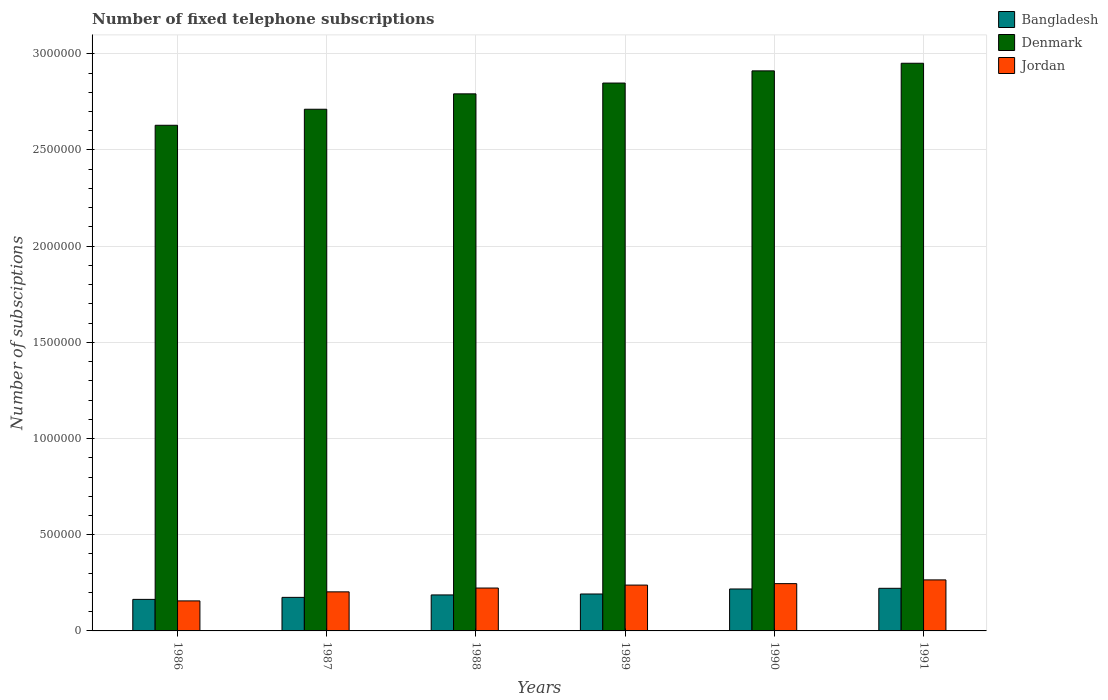How many different coloured bars are there?
Keep it short and to the point. 3. How many groups of bars are there?
Your response must be concise. 6. Are the number of bars per tick equal to the number of legend labels?
Provide a short and direct response. Yes. How many bars are there on the 4th tick from the right?
Offer a terse response. 3. In how many cases, is the number of bars for a given year not equal to the number of legend labels?
Provide a succinct answer. 0. What is the number of fixed telephone subscriptions in Bangladesh in 1987?
Give a very brief answer. 1.74e+05. Across all years, what is the maximum number of fixed telephone subscriptions in Jordan?
Provide a short and direct response. 2.65e+05. Across all years, what is the minimum number of fixed telephone subscriptions in Denmark?
Your response must be concise. 2.63e+06. In which year was the number of fixed telephone subscriptions in Jordan maximum?
Provide a succinct answer. 1991. In which year was the number of fixed telephone subscriptions in Denmark minimum?
Your answer should be compact. 1986. What is the total number of fixed telephone subscriptions in Bangladesh in the graph?
Offer a very short reply. 1.16e+06. What is the difference between the number of fixed telephone subscriptions in Bangladesh in 1987 and that in 1991?
Give a very brief answer. -4.71e+04. What is the difference between the number of fixed telephone subscriptions in Jordan in 1987 and the number of fixed telephone subscriptions in Bangladesh in 1991?
Your answer should be compact. -1.85e+04. What is the average number of fixed telephone subscriptions in Denmark per year?
Your answer should be very brief. 2.81e+06. In the year 1990, what is the difference between the number of fixed telephone subscriptions in Bangladesh and number of fixed telephone subscriptions in Denmark?
Ensure brevity in your answer.  -2.69e+06. What is the ratio of the number of fixed telephone subscriptions in Bangladesh in 1988 to that in 1991?
Keep it short and to the point. 0.84. Is the number of fixed telephone subscriptions in Bangladesh in 1987 less than that in 1988?
Your response must be concise. Yes. Is the difference between the number of fixed telephone subscriptions in Bangladesh in 1987 and 1990 greater than the difference between the number of fixed telephone subscriptions in Denmark in 1987 and 1990?
Your answer should be compact. Yes. What is the difference between the highest and the second highest number of fixed telephone subscriptions in Denmark?
Ensure brevity in your answer.  3.96e+04. What is the difference between the highest and the lowest number of fixed telephone subscriptions in Denmark?
Keep it short and to the point. 3.22e+05. Is the sum of the number of fixed telephone subscriptions in Denmark in 1987 and 1989 greater than the maximum number of fixed telephone subscriptions in Jordan across all years?
Your response must be concise. Yes. What does the 1st bar from the left in 1989 represents?
Offer a terse response. Bangladesh. Is it the case that in every year, the sum of the number of fixed telephone subscriptions in Denmark and number of fixed telephone subscriptions in Bangladesh is greater than the number of fixed telephone subscriptions in Jordan?
Make the answer very short. Yes. Are all the bars in the graph horizontal?
Offer a terse response. No. Are the values on the major ticks of Y-axis written in scientific E-notation?
Make the answer very short. No. Does the graph contain any zero values?
Provide a short and direct response. No. Does the graph contain grids?
Your answer should be very brief. Yes. What is the title of the graph?
Give a very brief answer. Number of fixed telephone subscriptions. Does "United States" appear as one of the legend labels in the graph?
Your response must be concise. No. What is the label or title of the X-axis?
Your answer should be very brief. Years. What is the label or title of the Y-axis?
Offer a very short reply. Number of subsciptions. What is the Number of subsciptions in Bangladesh in 1986?
Provide a succinct answer. 1.64e+05. What is the Number of subsciptions of Denmark in 1986?
Provide a short and direct response. 2.63e+06. What is the Number of subsciptions of Jordan in 1986?
Give a very brief answer. 1.56e+05. What is the Number of subsciptions in Bangladesh in 1987?
Keep it short and to the point. 1.74e+05. What is the Number of subsciptions of Denmark in 1987?
Provide a short and direct response. 2.71e+06. What is the Number of subsciptions of Jordan in 1987?
Your answer should be very brief. 2.03e+05. What is the Number of subsciptions of Bangladesh in 1988?
Keep it short and to the point. 1.87e+05. What is the Number of subsciptions of Denmark in 1988?
Your response must be concise. 2.79e+06. What is the Number of subsciptions in Jordan in 1988?
Keep it short and to the point. 2.23e+05. What is the Number of subsciptions of Bangladesh in 1989?
Offer a very short reply. 1.92e+05. What is the Number of subsciptions in Denmark in 1989?
Keep it short and to the point. 2.85e+06. What is the Number of subsciptions in Jordan in 1989?
Give a very brief answer. 2.38e+05. What is the Number of subsciptions in Bangladesh in 1990?
Give a very brief answer. 2.18e+05. What is the Number of subsciptions of Denmark in 1990?
Offer a terse response. 2.91e+06. What is the Number of subsciptions in Jordan in 1990?
Give a very brief answer. 2.46e+05. What is the Number of subsciptions of Bangladesh in 1991?
Provide a succinct answer. 2.22e+05. What is the Number of subsciptions of Denmark in 1991?
Offer a very short reply. 2.95e+06. What is the Number of subsciptions in Jordan in 1991?
Give a very brief answer. 2.65e+05. Across all years, what is the maximum Number of subsciptions in Bangladesh?
Your response must be concise. 2.22e+05. Across all years, what is the maximum Number of subsciptions of Denmark?
Provide a succinct answer. 2.95e+06. Across all years, what is the maximum Number of subsciptions in Jordan?
Your response must be concise. 2.65e+05. Across all years, what is the minimum Number of subsciptions in Bangladesh?
Ensure brevity in your answer.  1.64e+05. Across all years, what is the minimum Number of subsciptions in Denmark?
Your answer should be very brief. 2.63e+06. Across all years, what is the minimum Number of subsciptions of Jordan?
Offer a terse response. 1.56e+05. What is the total Number of subsciptions in Bangladesh in the graph?
Make the answer very short. 1.16e+06. What is the total Number of subsciptions in Denmark in the graph?
Provide a succinct answer. 1.68e+07. What is the total Number of subsciptions of Jordan in the graph?
Your answer should be very brief. 1.33e+06. What is the difference between the Number of subsciptions in Bangladesh in 1986 and that in 1987?
Your answer should be very brief. -1.05e+04. What is the difference between the Number of subsciptions of Denmark in 1986 and that in 1987?
Your response must be concise. -8.33e+04. What is the difference between the Number of subsciptions of Jordan in 1986 and that in 1987?
Provide a succinct answer. -4.70e+04. What is the difference between the Number of subsciptions of Bangladesh in 1986 and that in 1988?
Make the answer very short. -2.32e+04. What is the difference between the Number of subsciptions of Denmark in 1986 and that in 1988?
Your response must be concise. -1.63e+05. What is the difference between the Number of subsciptions in Jordan in 1986 and that in 1988?
Keep it short and to the point. -6.69e+04. What is the difference between the Number of subsciptions of Bangladesh in 1986 and that in 1989?
Your answer should be compact. -2.81e+04. What is the difference between the Number of subsciptions in Denmark in 1986 and that in 1989?
Your answer should be very brief. -2.20e+05. What is the difference between the Number of subsciptions in Jordan in 1986 and that in 1989?
Provide a succinct answer. -8.23e+04. What is the difference between the Number of subsciptions of Bangladesh in 1986 and that in 1990?
Give a very brief answer. -5.41e+04. What is the difference between the Number of subsciptions in Denmark in 1986 and that in 1990?
Offer a terse response. -2.83e+05. What is the difference between the Number of subsciptions of Jordan in 1986 and that in 1990?
Make the answer very short. -8.98e+04. What is the difference between the Number of subsciptions of Bangladesh in 1986 and that in 1991?
Your answer should be compact. -5.76e+04. What is the difference between the Number of subsciptions of Denmark in 1986 and that in 1991?
Make the answer very short. -3.22e+05. What is the difference between the Number of subsciptions of Jordan in 1986 and that in 1991?
Ensure brevity in your answer.  -1.09e+05. What is the difference between the Number of subsciptions of Bangladesh in 1987 and that in 1988?
Ensure brevity in your answer.  -1.27e+04. What is the difference between the Number of subsciptions in Denmark in 1987 and that in 1988?
Provide a succinct answer. -8.00e+04. What is the difference between the Number of subsciptions of Jordan in 1987 and that in 1988?
Keep it short and to the point. -1.98e+04. What is the difference between the Number of subsciptions in Bangladesh in 1987 and that in 1989?
Make the answer very short. -1.76e+04. What is the difference between the Number of subsciptions in Denmark in 1987 and that in 1989?
Your response must be concise. -1.36e+05. What is the difference between the Number of subsciptions in Jordan in 1987 and that in 1989?
Offer a terse response. -3.52e+04. What is the difference between the Number of subsciptions in Bangladesh in 1987 and that in 1990?
Your response must be concise. -4.36e+04. What is the difference between the Number of subsciptions in Denmark in 1987 and that in 1990?
Your response must be concise. -2.00e+05. What is the difference between the Number of subsciptions of Jordan in 1987 and that in 1990?
Provide a short and direct response. -4.27e+04. What is the difference between the Number of subsciptions of Bangladesh in 1987 and that in 1991?
Offer a very short reply. -4.71e+04. What is the difference between the Number of subsciptions in Denmark in 1987 and that in 1991?
Make the answer very short. -2.39e+05. What is the difference between the Number of subsciptions in Jordan in 1987 and that in 1991?
Your answer should be very brief. -6.22e+04. What is the difference between the Number of subsciptions of Bangladesh in 1988 and that in 1989?
Provide a short and direct response. -4900. What is the difference between the Number of subsciptions in Denmark in 1988 and that in 1989?
Your answer should be very brief. -5.61e+04. What is the difference between the Number of subsciptions of Jordan in 1988 and that in 1989?
Give a very brief answer. -1.54e+04. What is the difference between the Number of subsciptions in Bangladesh in 1988 and that in 1990?
Your answer should be compact. -3.09e+04. What is the difference between the Number of subsciptions of Denmark in 1988 and that in 1990?
Give a very brief answer. -1.19e+05. What is the difference between the Number of subsciptions of Jordan in 1988 and that in 1990?
Make the answer very short. -2.29e+04. What is the difference between the Number of subsciptions of Bangladesh in 1988 and that in 1991?
Provide a short and direct response. -3.44e+04. What is the difference between the Number of subsciptions in Denmark in 1988 and that in 1991?
Your answer should be compact. -1.59e+05. What is the difference between the Number of subsciptions of Jordan in 1988 and that in 1991?
Offer a very short reply. -4.23e+04. What is the difference between the Number of subsciptions in Bangladesh in 1989 and that in 1990?
Provide a short and direct response. -2.60e+04. What is the difference between the Number of subsciptions of Denmark in 1989 and that in 1990?
Provide a succinct answer. -6.33e+04. What is the difference between the Number of subsciptions of Jordan in 1989 and that in 1990?
Your response must be concise. -7490. What is the difference between the Number of subsciptions in Bangladesh in 1989 and that in 1991?
Keep it short and to the point. -2.95e+04. What is the difference between the Number of subsciptions in Denmark in 1989 and that in 1991?
Give a very brief answer. -1.03e+05. What is the difference between the Number of subsciptions of Jordan in 1989 and that in 1991?
Provide a short and direct response. -2.69e+04. What is the difference between the Number of subsciptions in Bangladesh in 1990 and that in 1991?
Your answer should be very brief. -3513. What is the difference between the Number of subsciptions in Denmark in 1990 and that in 1991?
Ensure brevity in your answer.  -3.96e+04. What is the difference between the Number of subsciptions of Jordan in 1990 and that in 1991?
Give a very brief answer. -1.94e+04. What is the difference between the Number of subsciptions of Bangladesh in 1986 and the Number of subsciptions of Denmark in 1987?
Offer a terse response. -2.55e+06. What is the difference between the Number of subsciptions of Bangladesh in 1986 and the Number of subsciptions of Jordan in 1987?
Provide a short and direct response. -3.92e+04. What is the difference between the Number of subsciptions in Denmark in 1986 and the Number of subsciptions in Jordan in 1987?
Keep it short and to the point. 2.43e+06. What is the difference between the Number of subsciptions in Bangladesh in 1986 and the Number of subsciptions in Denmark in 1988?
Offer a terse response. -2.63e+06. What is the difference between the Number of subsciptions of Bangladesh in 1986 and the Number of subsciptions of Jordan in 1988?
Your answer should be very brief. -5.90e+04. What is the difference between the Number of subsciptions of Denmark in 1986 and the Number of subsciptions of Jordan in 1988?
Provide a succinct answer. 2.41e+06. What is the difference between the Number of subsciptions in Bangladesh in 1986 and the Number of subsciptions in Denmark in 1989?
Give a very brief answer. -2.68e+06. What is the difference between the Number of subsciptions of Bangladesh in 1986 and the Number of subsciptions of Jordan in 1989?
Your response must be concise. -7.44e+04. What is the difference between the Number of subsciptions of Denmark in 1986 and the Number of subsciptions of Jordan in 1989?
Offer a very short reply. 2.39e+06. What is the difference between the Number of subsciptions in Bangladesh in 1986 and the Number of subsciptions in Denmark in 1990?
Offer a very short reply. -2.75e+06. What is the difference between the Number of subsciptions in Bangladesh in 1986 and the Number of subsciptions in Jordan in 1990?
Offer a terse response. -8.19e+04. What is the difference between the Number of subsciptions in Denmark in 1986 and the Number of subsciptions in Jordan in 1990?
Your answer should be compact. 2.38e+06. What is the difference between the Number of subsciptions of Bangladesh in 1986 and the Number of subsciptions of Denmark in 1991?
Provide a short and direct response. -2.79e+06. What is the difference between the Number of subsciptions in Bangladesh in 1986 and the Number of subsciptions in Jordan in 1991?
Provide a short and direct response. -1.01e+05. What is the difference between the Number of subsciptions of Denmark in 1986 and the Number of subsciptions of Jordan in 1991?
Your answer should be compact. 2.36e+06. What is the difference between the Number of subsciptions in Bangladesh in 1987 and the Number of subsciptions in Denmark in 1988?
Provide a succinct answer. -2.62e+06. What is the difference between the Number of subsciptions of Bangladesh in 1987 and the Number of subsciptions of Jordan in 1988?
Provide a succinct answer. -4.85e+04. What is the difference between the Number of subsciptions of Denmark in 1987 and the Number of subsciptions of Jordan in 1988?
Your answer should be very brief. 2.49e+06. What is the difference between the Number of subsciptions in Bangladesh in 1987 and the Number of subsciptions in Denmark in 1989?
Offer a very short reply. -2.67e+06. What is the difference between the Number of subsciptions in Bangladesh in 1987 and the Number of subsciptions in Jordan in 1989?
Give a very brief answer. -6.39e+04. What is the difference between the Number of subsciptions in Denmark in 1987 and the Number of subsciptions in Jordan in 1989?
Ensure brevity in your answer.  2.47e+06. What is the difference between the Number of subsciptions of Bangladesh in 1987 and the Number of subsciptions of Denmark in 1990?
Your response must be concise. -2.74e+06. What is the difference between the Number of subsciptions in Bangladesh in 1987 and the Number of subsciptions in Jordan in 1990?
Make the answer very short. -7.14e+04. What is the difference between the Number of subsciptions in Denmark in 1987 and the Number of subsciptions in Jordan in 1990?
Provide a succinct answer. 2.47e+06. What is the difference between the Number of subsciptions in Bangladesh in 1987 and the Number of subsciptions in Denmark in 1991?
Your response must be concise. -2.78e+06. What is the difference between the Number of subsciptions of Bangladesh in 1987 and the Number of subsciptions of Jordan in 1991?
Provide a succinct answer. -9.08e+04. What is the difference between the Number of subsciptions in Denmark in 1987 and the Number of subsciptions in Jordan in 1991?
Ensure brevity in your answer.  2.45e+06. What is the difference between the Number of subsciptions in Bangladesh in 1988 and the Number of subsciptions in Denmark in 1989?
Keep it short and to the point. -2.66e+06. What is the difference between the Number of subsciptions in Bangladesh in 1988 and the Number of subsciptions in Jordan in 1989?
Provide a short and direct response. -5.12e+04. What is the difference between the Number of subsciptions of Denmark in 1988 and the Number of subsciptions of Jordan in 1989?
Your response must be concise. 2.55e+06. What is the difference between the Number of subsciptions of Bangladesh in 1988 and the Number of subsciptions of Denmark in 1990?
Make the answer very short. -2.72e+06. What is the difference between the Number of subsciptions in Bangladesh in 1988 and the Number of subsciptions in Jordan in 1990?
Offer a terse response. -5.87e+04. What is the difference between the Number of subsciptions in Denmark in 1988 and the Number of subsciptions in Jordan in 1990?
Your answer should be very brief. 2.55e+06. What is the difference between the Number of subsciptions of Bangladesh in 1988 and the Number of subsciptions of Denmark in 1991?
Keep it short and to the point. -2.76e+06. What is the difference between the Number of subsciptions in Bangladesh in 1988 and the Number of subsciptions in Jordan in 1991?
Keep it short and to the point. -7.81e+04. What is the difference between the Number of subsciptions in Denmark in 1988 and the Number of subsciptions in Jordan in 1991?
Your answer should be compact. 2.53e+06. What is the difference between the Number of subsciptions of Bangladesh in 1989 and the Number of subsciptions of Denmark in 1990?
Provide a succinct answer. -2.72e+06. What is the difference between the Number of subsciptions of Bangladesh in 1989 and the Number of subsciptions of Jordan in 1990?
Ensure brevity in your answer.  -5.38e+04. What is the difference between the Number of subsciptions in Denmark in 1989 and the Number of subsciptions in Jordan in 1990?
Offer a very short reply. 2.60e+06. What is the difference between the Number of subsciptions of Bangladesh in 1989 and the Number of subsciptions of Denmark in 1991?
Your answer should be compact. -2.76e+06. What is the difference between the Number of subsciptions of Bangladesh in 1989 and the Number of subsciptions of Jordan in 1991?
Offer a very short reply. -7.32e+04. What is the difference between the Number of subsciptions in Denmark in 1989 and the Number of subsciptions in Jordan in 1991?
Give a very brief answer. 2.58e+06. What is the difference between the Number of subsciptions in Bangladesh in 1990 and the Number of subsciptions in Denmark in 1991?
Your answer should be compact. -2.73e+06. What is the difference between the Number of subsciptions in Bangladesh in 1990 and the Number of subsciptions in Jordan in 1991?
Your answer should be compact. -4.72e+04. What is the difference between the Number of subsciptions of Denmark in 1990 and the Number of subsciptions of Jordan in 1991?
Ensure brevity in your answer.  2.65e+06. What is the average Number of subsciptions of Bangladesh per year?
Your response must be concise. 1.93e+05. What is the average Number of subsciptions of Denmark per year?
Give a very brief answer. 2.81e+06. What is the average Number of subsciptions in Jordan per year?
Give a very brief answer. 2.22e+05. In the year 1986, what is the difference between the Number of subsciptions in Bangladesh and Number of subsciptions in Denmark?
Your answer should be compact. -2.46e+06. In the year 1986, what is the difference between the Number of subsciptions in Bangladesh and Number of subsciptions in Jordan?
Ensure brevity in your answer.  7876. In the year 1986, what is the difference between the Number of subsciptions in Denmark and Number of subsciptions in Jordan?
Your response must be concise. 2.47e+06. In the year 1987, what is the difference between the Number of subsciptions of Bangladesh and Number of subsciptions of Denmark?
Keep it short and to the point. -2.54e+06. In the year 1987, what is the difference between the Number of subsciptions of Bangladesh and Number of subsciptions of Jordan?
Ensure brevity in your answer.  -2.87e+04. In the year 1987, what is the difference between the Number of subsciptions of Denmark and Number of subsciptions of Jordan?
Keep it short and to the point. 2.51e+06. In the year 1988, what is the difference between the Number of subsciptions in Bangladesh and Number of subsciptions in Denmark?
Provide a short and direct response. -2.60e+06. In the year 1988, what is the difference between the Number of subsciptions in Bangladesh and Number of subsciptions in Jordan?
Keep it short and to the point. -3.58e+04. In the year 1988, what is the difference between the Number of subsciptions in Denmark and Number of subsciptions in Jordan?
Your response must be concise. 2.57e+06. In the year 1989, what is the difference between the Number of subsciptions of Bangladesh and Number of subsciptions of Denmark?
Your response must be concise. -2.66e+06. In the year 1989, what is the difference between the Number of subsciptions of Bangladesh and Number of subsciptions of Jordan?
Keep it short and to the point. -4.63e+04. In the year 1989, what is the difference between the Number of subsciptions in Denmark and Number of subsciptions in Jordan?
Offer a terse response. 2.61e+06. In the year 1990, what is the difference between the Number of subsciptions in Bangladesh and Number of subsciptions in Denmark?
Ensure brevity in your answer.  -2.69e+06. In the year 1990, what is the difference between the Number of subsciptions in Bangladesh and Number of subsciptions in Jordan?
Keep it short and to the point. -2.78e+04. In the year 1990, what is the difference between the Number of subsciptions of Denmark and Number of subsciptions of Jordan?
Your answer should be compact. 2.67e+06. In the year 1991, what is the difference between the Number of subsciptions of Bangladesh and Number of subsciptions of Denmark?
Your answer should be very brief. -2.73e+06. In the year 1991, what is the difference between the Number of subsciptions of Bangladesh and Number of subsciptions of Jordan?
Provide a short and direct response. -4.37e+04. In the year 1991, what is the difference between the Number of subsciptions in Denmark and Number of subsciptions in Jordan?
Make the answer very short. 2.69e+06. What is the ratio of the Number of subsciptions in Bangladesh in 1986 to that in 1987?
Offer a terse response. 0.94. What is the ratio of the Number of subsciptions of Denmark in 1986 to that in 1987?
Provide a short and direct response. 0.97. What is the ratio of the Number of subsciptions of Jordan in 1986 to that in 1987?
Offer a terse response. 0.77. What is the ratio of the Number of subsciptions of Bangladesh in 1986 to that in 1988?
Your answer should be very brief. 0.88. What is the ratio of the Number of subsciptions of Denmark in 1986 to that in 1988?
Keep it short and to the point. 0.94. What is the ratio of the Number of subsciptions of Jordan in 1986 to that in 1988?
Make the answer very short. 0.7. What is the ratio of the Number of subsciptions of Bangladesh in 1986 to that in 1989?
Make the answer very short. 0.85. What is the ratio of the Number of subsciptions in Denmark in 1986 to that in 1989?
Give a very brief answer. 0.92. What is the ratio of the Number of subsciptions in Jordan in 1986 to that in 1989?
Your response must be concise. 0.65. What is the ratio of the Number of subsciptions of Bangladesh in 1986 to that in 1990?
Give a very brief answer. 0.75. What is the ratio of the Number of subsciptions in Denmark in 1986 to that in 1990?
Offer a terse response. 0.9. What is the ratio of the Number of subsciptions of Jordan in 1986 to that in 1990?
Offer a very short reply. 0.63. What is the ratio of the Number of subsciptions in Bangladesh in 1986 to that in 1991?
Make the answer very short. 0.74. What is the ratio of the Number of subsciptions in Denmark in 1986 to that in 1991?
Offer a very short reply. 0.89. What is the ratio of the Number of subsciptions in Jordan in 1986 to that in 1991?
Offer a very short reply. 0.59. What is the ratio of the Number of subsciptions of Bangladesh in 1987 to that in 1988?
Provide a short and direct response. 0.93. What is the ratio of the Number of subsciptions of Denmark in 1987 to that in 1988?
Provide a succinct answer. 0.97. What is the ratio of the Number of subsciptions of Jordan in 1987 to that in 1988?
Provide a succinct answer. 0.91. What is the ratio of the Number of subsciptions of Bangladesh in 1987 to that in 1989?
Offer a terse response. 0.91. What is the ratio of the Number of subsciptions in Denmark in 1987 to that in 1989?
Offer a very short reply. 0.95. What is the ratio of the Number of subsciptions in Jordan in 1987 to that in 1989?
Keep it short and to the point. 0.85. What is the ratio of the Number of subsciptions in Denmark in 1987 to that in 1990?
Give a very brief answer. 0.93. What is the ratio of the Number of subsciptions in Jordan in 1987 to that in 1990?
Offer a very short reply. 0.83. What is the ratio of the Number of subsciptions of Bangladesh in 1987 to that in 1991?
Your answer should be very brief. 0.79. What is the ratio of the Number of subsciptions of Denmark in 1987 to that in 1991?
Offer a terse response. 0.92. What is the ratio of the Number of subsciptions of Jordan in 1987 to that in 1991?
Your response must be concise. 0.77. What is the ratio of the Number of subsciptions in Bangladesh in 1988 to that in 1989?
Give a very brief answer. 0.97. What is the ratio of the Number of subsciptions in Denmark in 1988 to that in 1989?
Your answer should be compact. 0.98. What is the ratio of the Number of subsciptions in Jordan in 1988 to that in 1989?
Your answer should be compact. 0.94. What is the ratio of the Number of subsciptions of Bangladesh in 1988 to that in 1990?
Provide a short and direct response. 0.86. What is the ratio of the Number of subsciptions in Jordan in 1988 to that in 1990?
Ensure brevity in your answer.  0.91. What is the ratio of the Number of subsciptions in Bangladesh in 1988 to that in 1991?
Offer a terse response. 0.84. What is the ratio of the Number of subsciptions of Denmark in 1988 to that in 1991?
Make the answer very short. 0.95. What is the ratio of the Number of subsciptions of Jordan in 1988 to that in 1991?
Provide a short and direct response. 0.84. What is the ratio of the Number of subsciptions in Bangladesh in 1989 to that in 1990?
Provide a succinct answer. 0.88. What is the ratio of the Number of subsciptions in Denmark in 1989 to that in 1990?
Your answer should be compact. 0.98. What is the ratio of the Number of subsciptions of Jordan in 1989 to that in 1990?
Provide a succinct answer. 0.97. What is the ratio of the Number of subsciptions in Bangladesh in 1989 to that in 1991?
Make the answer very short. 0.87. What is the ratio of the Number of subsciptions in Denmark in 1989 to that in 1991?
Offer a very short reply. 0.97. What is the ratio of the Number of subsciptions of Jordan in 1989 to that in 1991?
Ensure brevity in your answer.  0.9. What is the ratio of the Number of subsciptions of Bangladesh in 1990 to that in 1991?
Provide a short and direct response. 0.98. What is the ratio of the Number of subsciptions in Denmark in 1990 to that in 1991?
Offer a terse response. 0.99. What is the ratio of the Number of subsciptions in Jordan in 1990 to that in 1991?
Provide a succinct answer. 0.93. What is the difference between the highest and the second highest Number of subsciptions in Bangladesh?
Give a very brief answer. 3513. What is the difference between the highest and the second highest Number of subsciptions in Denmark?
Offer a terse response. 3.96e+04. What is the difference between the highest and the second highest Number of subsciptions of Jordan?
Ensure brevity in your answer.  1.94e+04. What is the difference between the highest and the lowest Number of subsciptions in Bangladesh?
Offer a very short reply. 5.76e+04. What is the difference between the highest and the lowest Number of subsciptions of Denmark?
Offer a terse response. 3.22e+05. What is the difference between the highest and the lowest Number of subsciptions in Jordan?
Offer a terse response. 1.09e+05. 